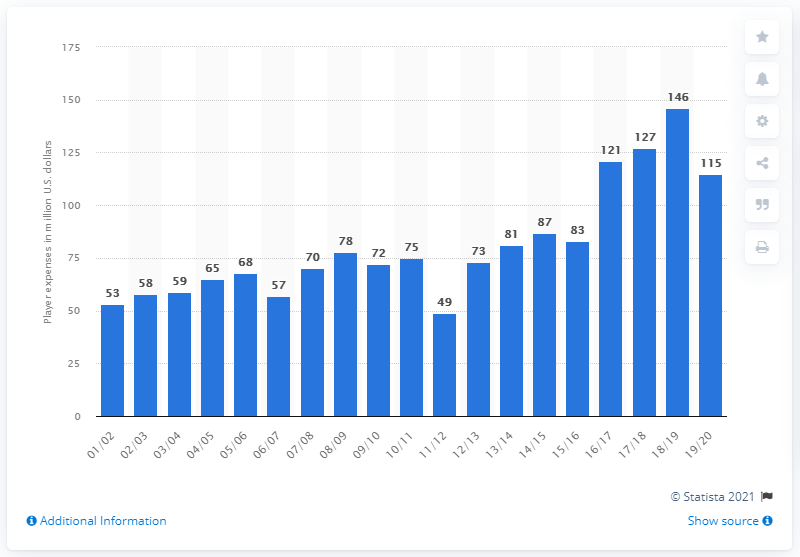Specify some key components in this picture. The player salaries of the Toronto Raptors in the 2019/20 season were approximately $115 million. 